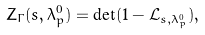Convert formula to latex. <formula><loc_0><loc_0><loc_500><loc_500>Z _ { \Gamma } ( s , \lambda _ { p } ^ { 0 } ) = \det ( 1 - \mathcal { L } _ { s , \lambda _ { p } ^ { 0 } } ) ,</formula> 